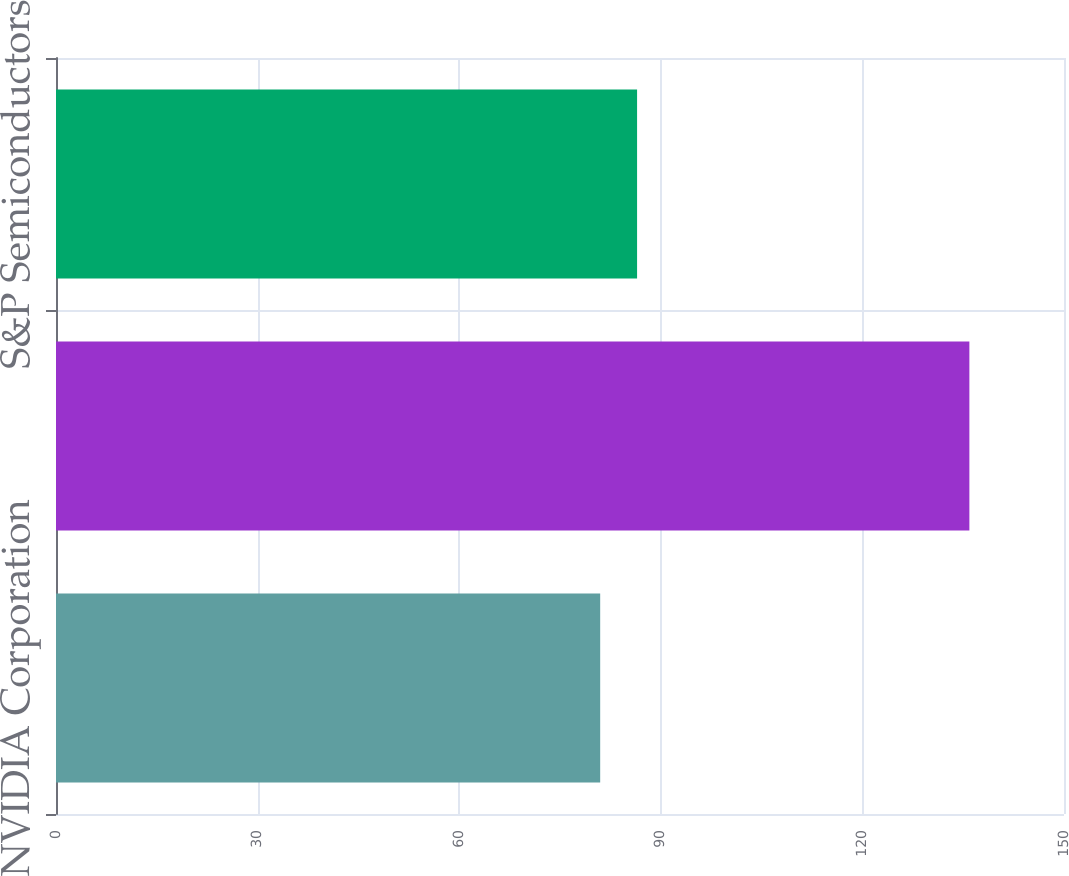<chart> <loc_0><loc_0><loc_500><loc_500><bar_chart><fcel>NVIDIA Corporation<fcel>S&P 500<fcel>S&P Semiconductors<nl><fcel>80.98<fcel>135.92<fcel>86.47<nl></chart> 